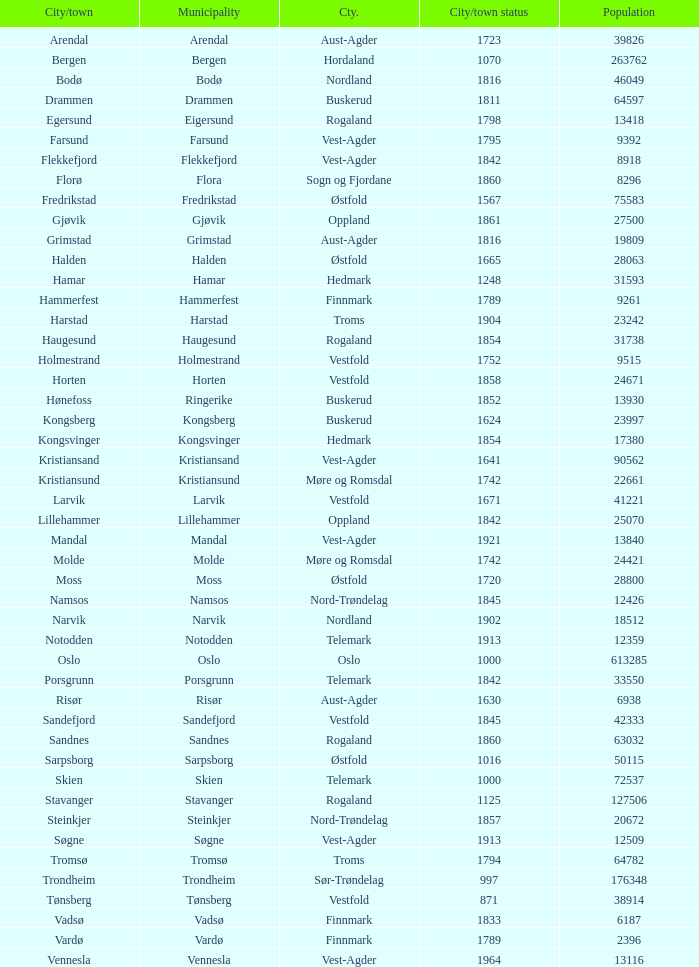Can you give me this table as a dict? {'header': ['City/town', 'Municipality', 'Cty.', 'City/town status', 'Population'], 'rows': [['Arendal', 'Arendal', 'Aust-Agder', '1723', '39826'], ['Bergen', 'Bergen', 'Hordaland', '1070', '263762'], ['Bodø', 'Bodø', 'Nordland', '1816', '46049'], ['Drammen', 'Drammen', 'Buskerud', '1811', '64597'], ['Egersund', 'Eigersund', 'Rogaland', '1798', '13418'], ['Farsund', 'Farsund', 'Vest-Agder', '1795', '9392'], ['Flekkefjord', 'Flekkefjord', 'Vest-Agder', '1842', '8918'], ['Florø', 'Flora', 'Sogn og Fjordane', '1860', '8296'], ['Fredrikstad', 'Fredrikstad', 'Østfold', '1567', '75583'], ['Gjøvik', 'Gjøvik', 'Oppland', '1861', '27500'], ['Grimstad', 'Grimstad', 'Aust-Agder', '1816', '19809'], ['Halden', 'Halden', 'Østfold', '1665', '28063'], ['Hamar', 'Hamar', 'Hedmark', '1248', '31593'], ['Hammerfest', 'Hammerfest', 'Finnmark', '1789', '9261'], ['Harstad', 'Harstad', 'Troms', '1904', '23242'], ['Haugesund', 'Haugesund', 'Rogaland', '1854', '31738'], ['Holmestrand', 'Holmestrand', 'Vestfold', '1752', '9515'], ['Horten', 'Horten', 'Vestfold', '1858', '24671'], ['Hønefoss', 'Ringerike', 'Buskerud', '1852', '13930'], ['Kongsberg', 'Kongsberg', 'Buskerud', '1624', '23997'], ['Kongsvinger', 'Kongsvinger', 'Hedmark', '1854', '17380'], ['Kristiansand', 'Kristiansand', 'Vest-Agder', '1641', '90562'], ['Kristiansund', 'Kristiansund', 'Møre og Romsdal', '1742', '22661'], ['Larvik', 'Larvik', 'Vestfold', '1671', '41221'], ['Lillehammer', 'Lillehammer', 'Oppland', '1842', '25070'], ['Mandal', 'Mandal', 'Vest-Agder', '1921', '13840'], ['Molde', 'Molde', 'Møre og Romsdal', '1742', '24421'], ['Moss', 'Moss', 'Østfold', '1720', '28800'], ['Namsos', 'Namsos', 'Nord-Trøndelag', '1845', '12426'], ['Narvik', 'Narvik', 'Nordland', '1902', '18512'], ['Notodden', 'Notodden', 'Telemark', '1913', '12359'], ['Oslo', 'Oslo', 'Oslo', '1000', '613285'], ['Porsgrunn', 'Porsgrunn', 'Telemark', '1842', '33550'], ['Risør', 'Risør', 'Aust-Agder', '1630', '6938'], ['Sandefjord', 'Sandefjord', 'Vestfold', '1845', '42333'], ['Sandnes', 'Sandnes', 'Rogaland', '1860', '63032'], ['Sarpsborg', 'Sarpsborg', 'Østfold', '1016', '50115'], ['Skien', 'Skien', 'Telemark', '1000', '72537'], ['Stavanger', 'Stavanger', 'Rogaland', '1125', '127506'], ['Steinkjer', 'Steinkjer', 'Nord-Trøndelag', '1857', '20672'], ['Søgne', 'Søgne', 'Vest-Agder', '1913', '12509'], ['Tromsø', 'Tromsø', 'Troms', '1794', '64782'], ['Trondheim', 'Trondheim', 'Sør-Trøndelag', '997', '176348'], ['Tønsberg', 'Tønsberg', 'Vestfold', '871', '38914'], ['Vadsø', 'Vadsø', 'Finnmark', '1833', '6187'], ['Vardø', 'Vardø', 'Finnmark', '1789', '2396'], ['Vennesla', 'Vennesla', 'Vest-Agder', '1964', '13116']]} Which localities within the finnmark county have populations greater than 618 Hammerfest. 